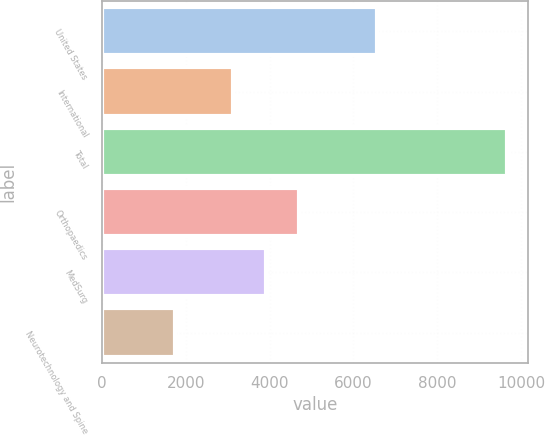<chart> <loc_0><loc_0><loc_500><loc_500><bar_chart><fcel>United States<fcel>International<fcel>Total<fcel>Orthopaedics<fcel>MedSurg<fcel>Neurotechnology and Spine<nl><fcel>6558<fcel>3117<fcel>9675<fcel>4703.8<fcel>3910.4<fcel>1741<nl></chart> 